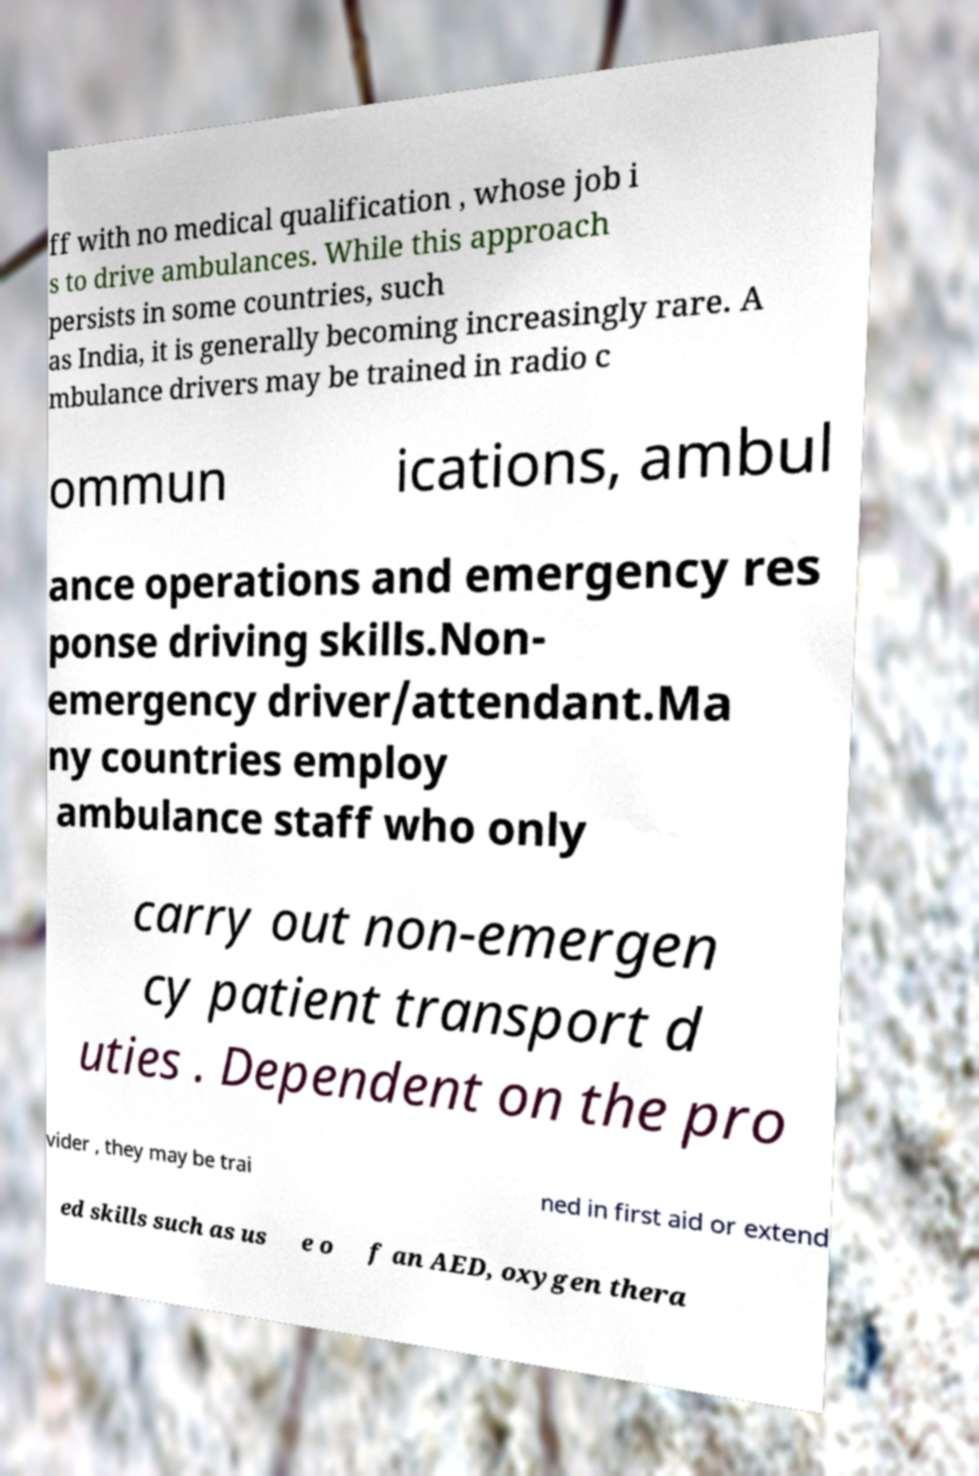Could you extract and type out the text from this image? ff with no medical qualification , whose job i s to drive ambulances. While this approach persists in some countries, such as India, it is generally becoming increasingly rare. A mbulance drivers may be trained in radio c ommun ications, ambul ance operations and emergency res ponse driving skills.Non- emergency driver/attendant.Ma ny countries employ ambulance staff who only carry out non-emergen cy patient transport d uties . Dependent on the pro vider , they may be trai ned in first aid or extend ed skills such as us e o f an AED, oxygen thera 